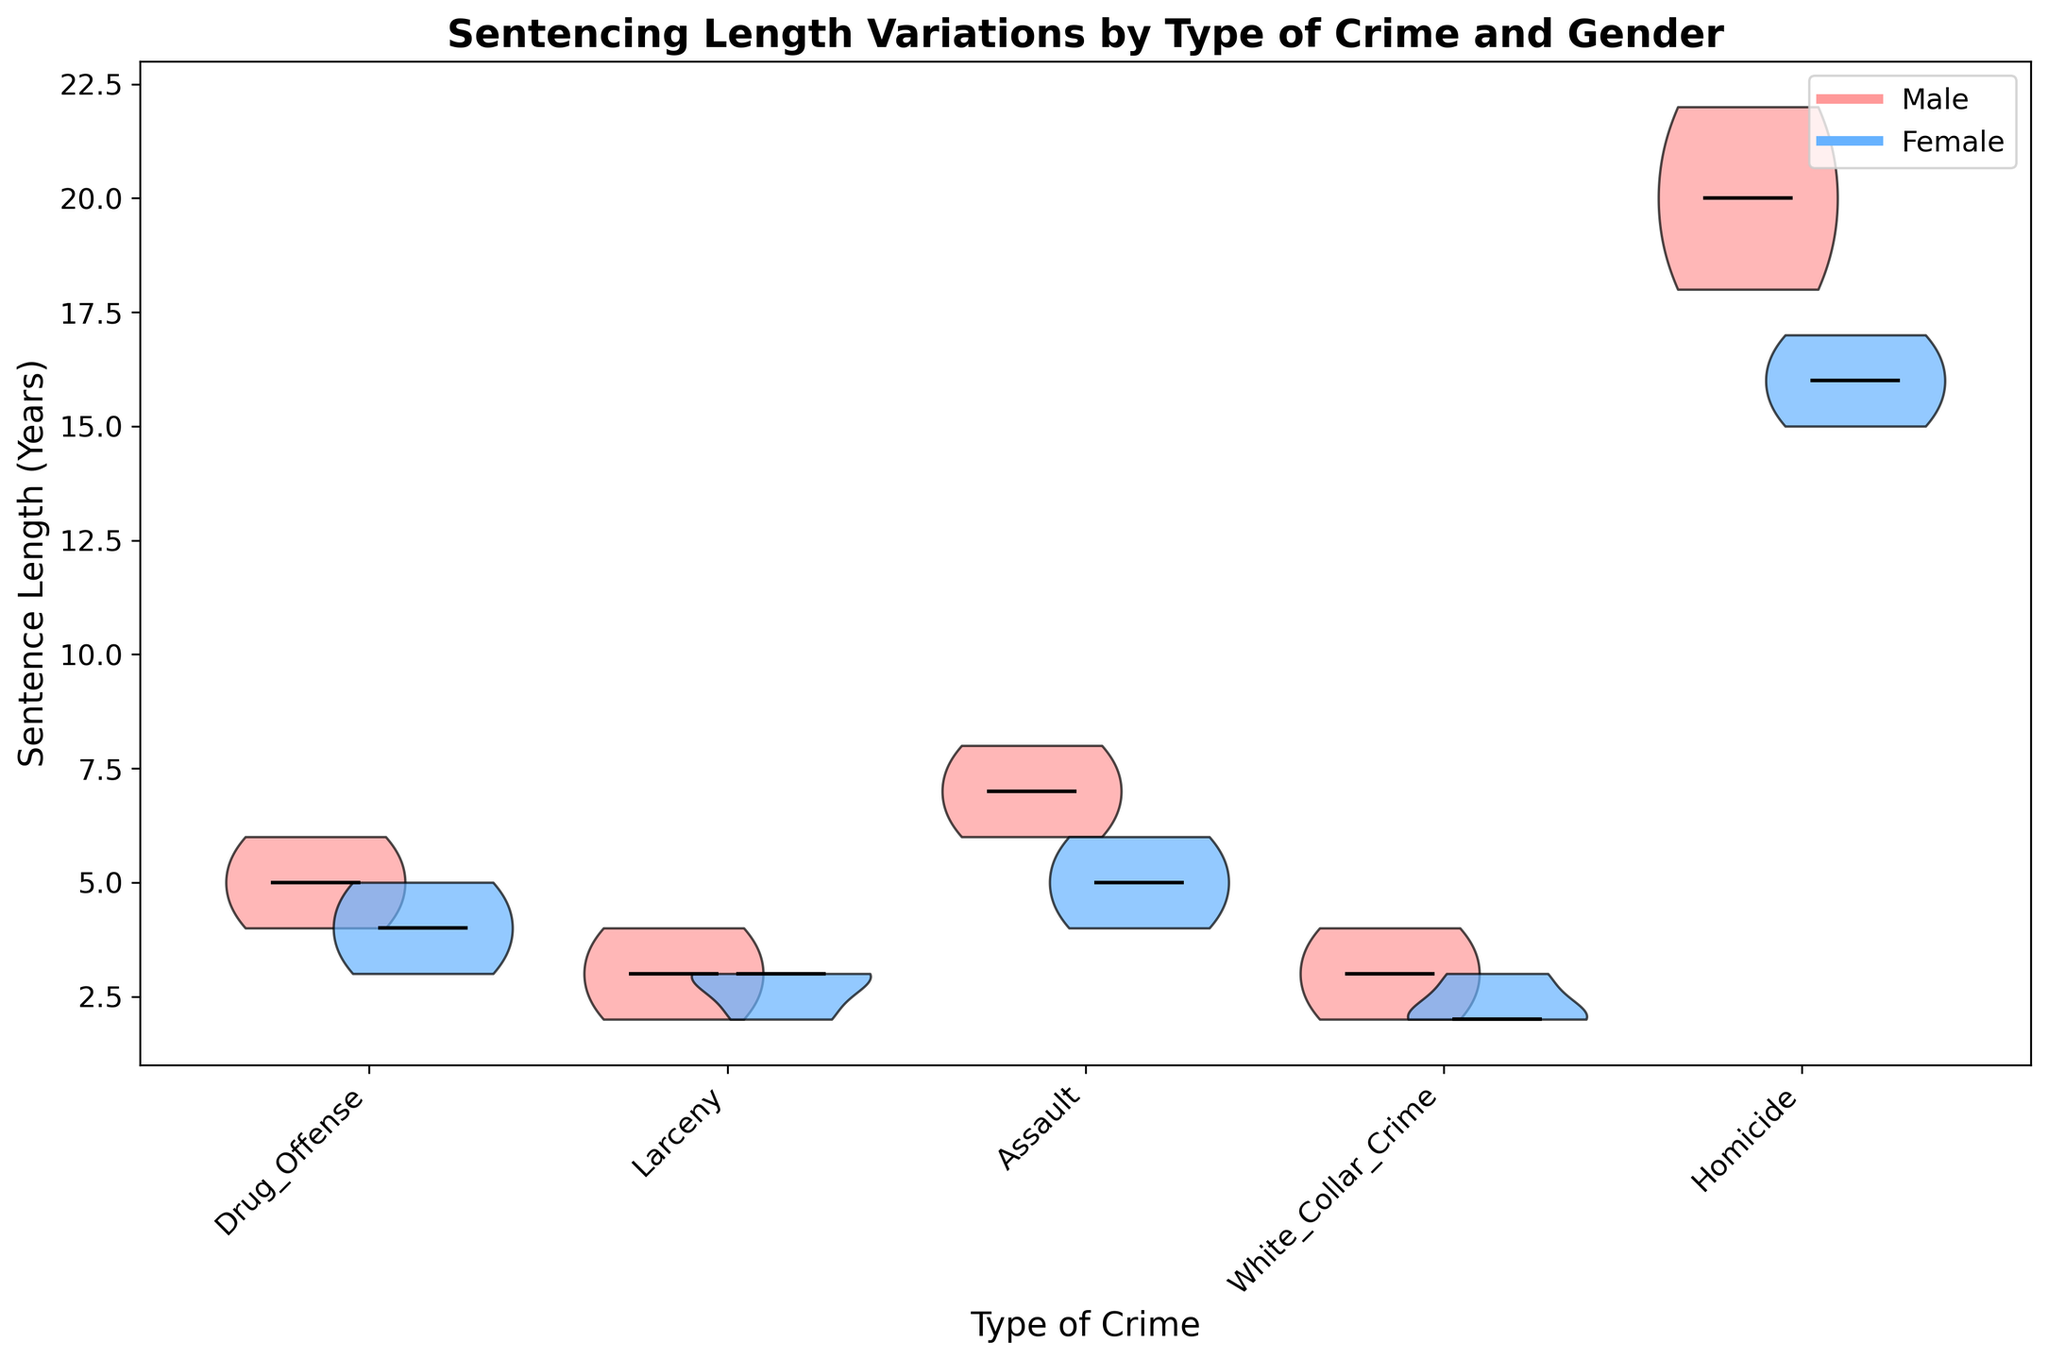What is the title of the figure? The title is displayed on top of the figure. It’s usually the first thing that catches attention in a plot.
Answer: Sentencing Length Variations by Type of Crime and Gender How is the x-axis labeled? The x-axis is labeled at the bottom of the plot. It typically gives information on what the different groups or categories in the plot represent.
Answer: Type of Crime What is the y-axis label in the figure? The y-axis label is along the vertical side of the plot, indicating what is being measured or the unit of measurement.
Answer: Sentence Length (Years) What does the black line inside each violin plot represent? The black line inside each violin indicates the median value of the sentence length for that particular category and gender.
Answer: Median value Which crime type has the highest median sentence length for males? To find this, look along the black lines inside each male violin plot and compare which one is at the highest position on the y-axis.
Answer: Homicide How do sentence lengths for drug offenses compare between males and females? Look at the position of the two violins for 'Drug_Offense', comparing their ranges and median lines.
Answer: Males have higher median and generally longer ranges compared to females Which gender has more variation in sentencing lengths for assault cases? Look at the spread or width of the violins for 'Assault' for both genders, comparing how stretched out they are vertically.
Answer: Males What is the typical range of sentence lengths for females involved in white-collar crime? Observe the top and bottom of the female 'White_Collar_Crime' violin plot to determine the range of sentence lengths.
Answer: 2-3 years Do males or females have a broader range of sentencing lengths for larceny? Compare the vertical spread of the 'Larceny' violins for both genders to see which one is wider.
Answer: Males How do sentencing ranges for homicide compare between males and females? Look at the violins for 'Homicide', comparing their height and the positions of median lines and the spreads.
Answer: Males have longer ranges and higher medians compared to females 